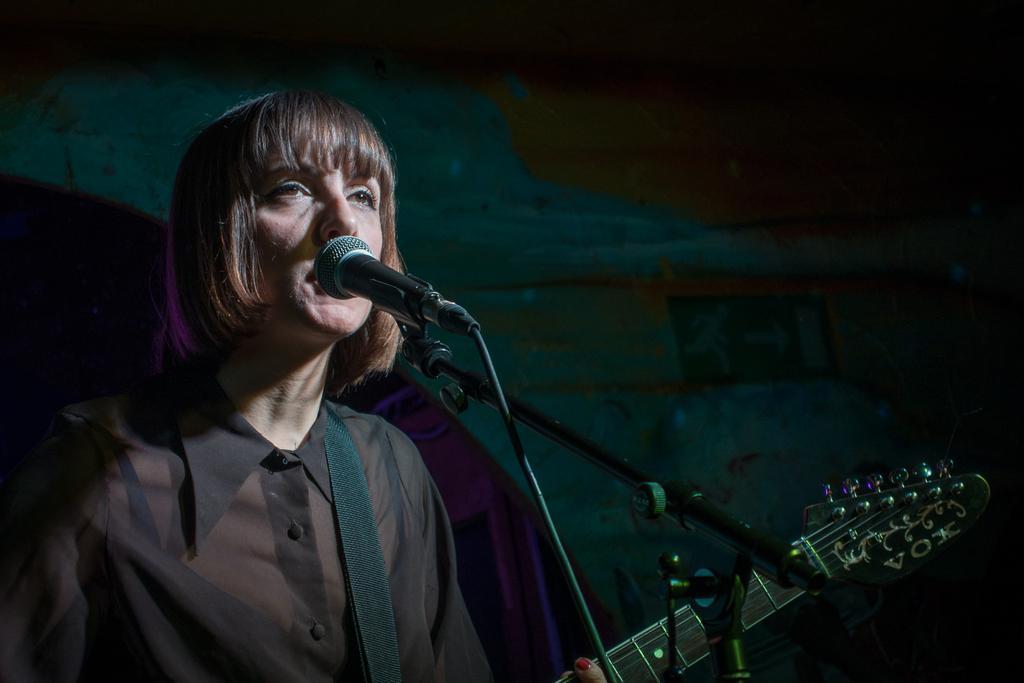In one or two sentences, can you explain what this image depicts? Background is dark. In this picture we can see a woman in front of a mike and she is holding a guitar in her hands. She wore black colour transparent shirt. 